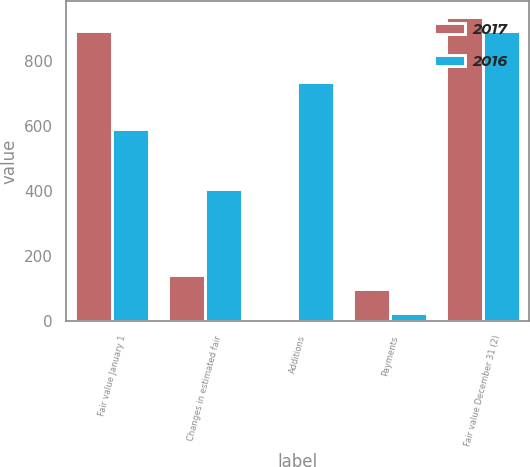Convert chart. <chart><loc_0><loc_0><loc_500><loc_500><stacked_bar_chart><ecel><fcel>Fair value January 1<fcel>Changes in estimated fair<fcel>Additions<fcel>Payments<fcel>Fair value December 31 (2)<nl><fcel>2017<fcel>891<fcel>141<fcel>3<fcel>100<fcel>935<nl><fcel>2016<fcel>590<fcel>407<fcel>733<fcel>25<fcel>891<nl></chart> 